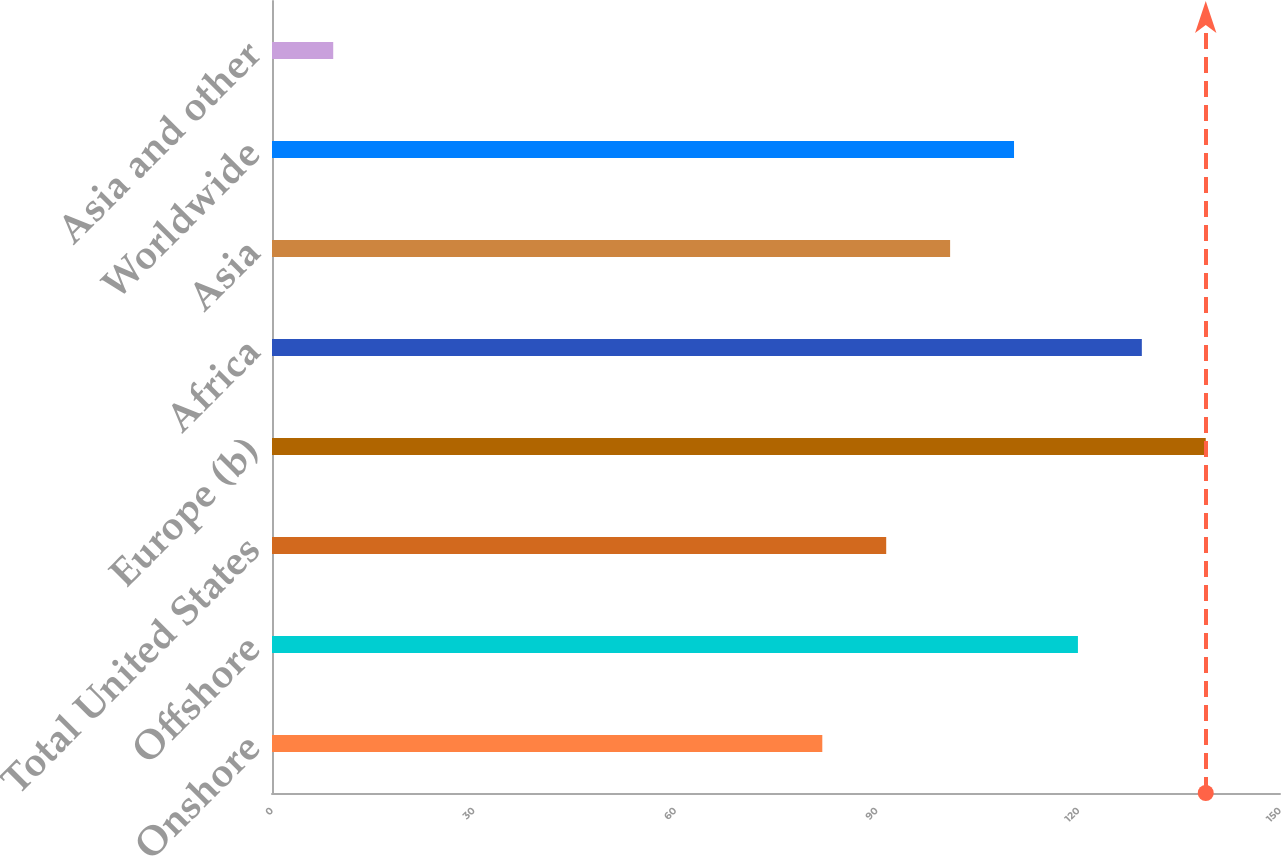<chart> <loc_0><loc_0><loc_500><loc_500><bar_chart><fcel>Onshore<fcel>Offshore<fcel>Total United States<fcel>Europe (b)<fcel>Africa<fcel>Asia<fcel>Worldwide<fcel>Asia and other<nl><fcel>81.89<fcel>119.93<fcel>91.4<fcel>138.95<fcel>129.44<fcel>100.91<fcel>110.42<fcel>9.11<nl></chart> 